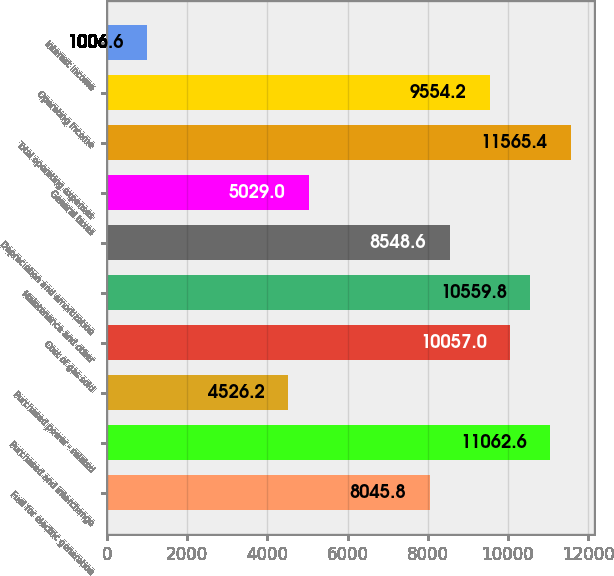Convert chart to OTSL. <chart><loc_0><loc_0><loc_500><loc_500><bar_chart><fcel>Fuel for electric generation<fcel>Purchased and interchange<fcel>Purchased power - related<fcel>Cost of gas sold<fcel>Maintenance and other<fcel>Depreciation and amortization<fcel>General taxes<fcel>Total operating expenses<fcel>Operating Income<fcel>Interest income<nl><fcel>8045.8<fcel>11062.6<fcel>4526.2<fcel>10057<fcel>10559.8<fcel>8548.6<fcel>5029<fcel>11565.4<fcel>9554.2<fcel>1006.6<nl></chart> 